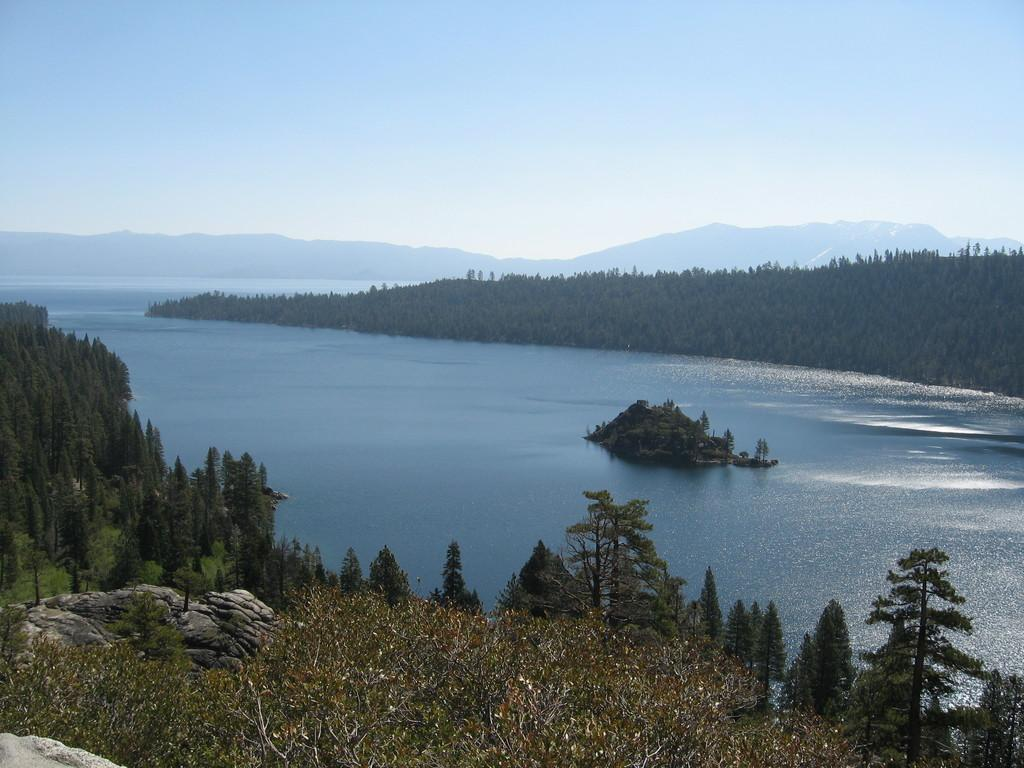What can be seen in the foreground of the image? There are trees and a rock in the foreground of the image. What is located in the middle of the image? There is a water body in the middle of the image, along with trees and a rock. What is visible in the background of the image? There are hills and trees in the background of the image. What part of the natural environment is visible at the top of the image? The sky is visible at the top of the image. Who is the owner of the trees in the image? There is no information about the ownership of the trees in the image. What hobbies do the rocks in the image enjoy? Rocks do not have hobbies, as they are inanimate objects. 